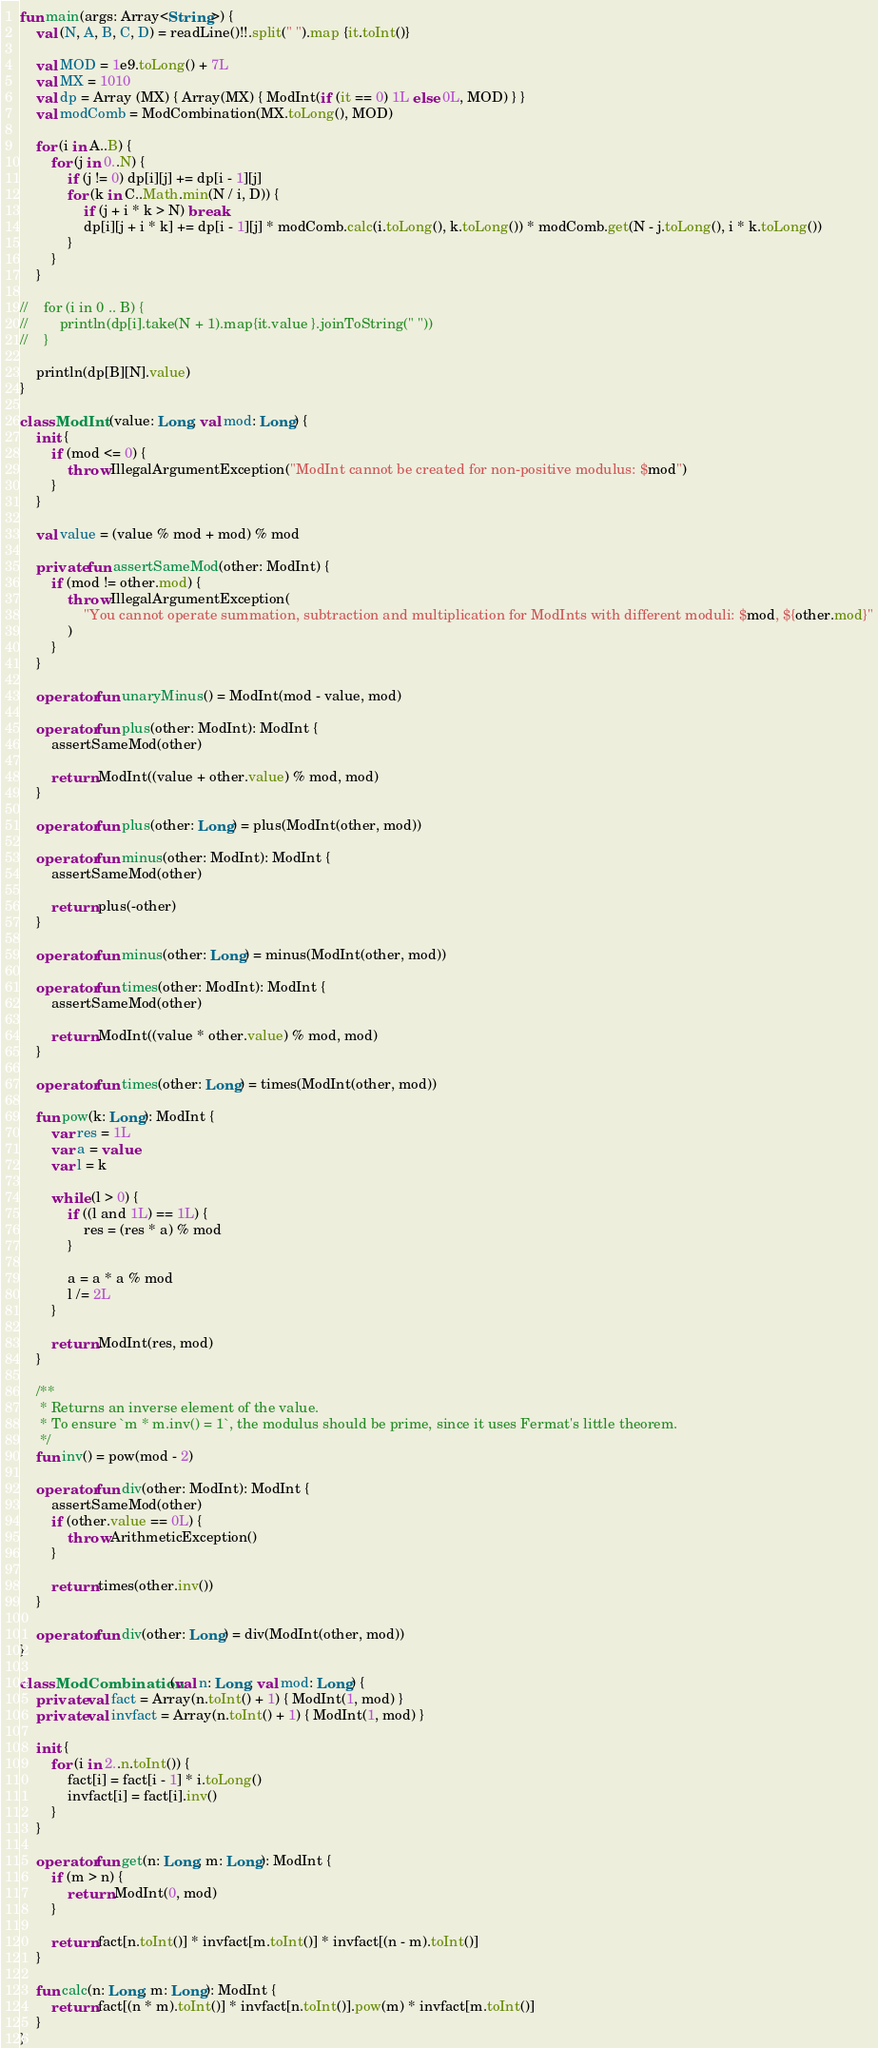Convert code to text. <code><loc_0><loc_0><loc_500><loc_500><_Kotlin_>fun main(args: Array<String>) {
    val (N, A, B, C, D) = readLine()!!.split(" ").map {it.toInt()}

    val MOD = 1e9.toLong() + 7L
    val MX = 1010
    val dp = Array (MX) { Array(MX) { ModInt(if (it == 0) 1L else 0L, MOD) } }
    val modComb = ModCombination(MX.toLong(), MOD)

    for (i in A..B) {
        for (j in 0..N) {
            if (j != 0) dp[i][j] += dp[i - 1][j]
            for (k in C..Math.min(N / i, D)) {
                if (j + i * k > N) break
                dp[i][j + i * k] += dp[i - 1][j] * modComb.calc(i.toLong(), k.toLong()) * modComb.get(N - j.toLong(), i * k.toLong())
            }
        }
    }

//    for (i in 0 .. B) {
//        println(dp[i].take(N + 1).map{it.value }.joinToString(" "))
//    }

    println(dp[B][N].value)
}

class ModInt (value: Long, val mod: Long) {
    init {
        if (mod <= 0) {
            throw IllegalArgumentException("ModInt cannot be created for non-positive modulus: $mod")
        }
    }

    val value = (value % mod + mod) % mod

    private fun assertSameMod(other: ModInt) {
        if (mod != other.mod) {
            throw IllegalArgumentException(
                "You cannot operate summation, subtraction and multiplication for ModInts with different moduli: $mod, ${other.mod}"
            )
        }
    }

    operator fun unaryMinus() = ModInt(mod - value, mod)

    operator fun plus(other: ModInt): ModInt {
        assertSameMod(other)

        return ModInt((value + other.value) % mod, mod)
    }

    operator fun plus(other: Long) = plus(ModInt(other, mod))

    operator fun minus(other: ModInt): ModInt {
        assertSameMod(other)

        return plus(-other)
    }

    operator fun minus(other: Long) = minus(ModInt(other, mod))

    operator fun times(other: ModInt): ModInt {
        assertSameMod(other)

        return ModInt((value * other.value) % mod, mod)
    }

    operator fun times(other: Long) = times(ModInt(other, mod))

    fun pow(k: Long): ModInt {
        var res = 1L
        var a = value
        var l = k

        while (l > 0) {
            if ((l and 1L) == 1L) {
                res = (res * a) % mod
            }

            a = a * a % mod
            l /= 2L
        }

        return ModInt(res, mod)
    }

    /**
     * Returns an inverse element of the value.
     * To ensure `m * m.inv() = 1`, the modulus should be prime, since it uses Fermat's little theorem.
     */
    fun inv() = pow(mod - 2)

    operator fun div(other: ModInt): ModInt {
        assertSameMod(other)
        if (other.value == 0L) {
            throw ArithmeticException()
        }

        return times(other.inv())
    }

    operator fun div(other: Long) = div(ModInt(other, mod))
}

class ModCombination(val n: Long, val mod: Long) {
    private val fact = Array(n.toInt() + 1) { ModInt(1, mod) }
    private val invfact = Array(n.toInt() + 1) { ModInt(1, mod) }

    init {
        for (i in 2..n.toInt()) {
            fact[i] = fact[i - 1] * i.toLong()
            invfact[i] = fact[i].inv()
        }
    }

    operator fun get(n: Long, m: Long): ModInt {
        if (m > n) {
            return ModInt(0, mod)
        }

        return fact[n.toInt()] * invfact[m.toInt()] * invfact[(n - m).toInt()]
    }

    fun calc(n: Long, m: Long): ModInt {
        return fact[(n * m).toInt()] * invfact[n.toInt()].pow(m) * invfact[m.toInt()]
    }
}
</code> 